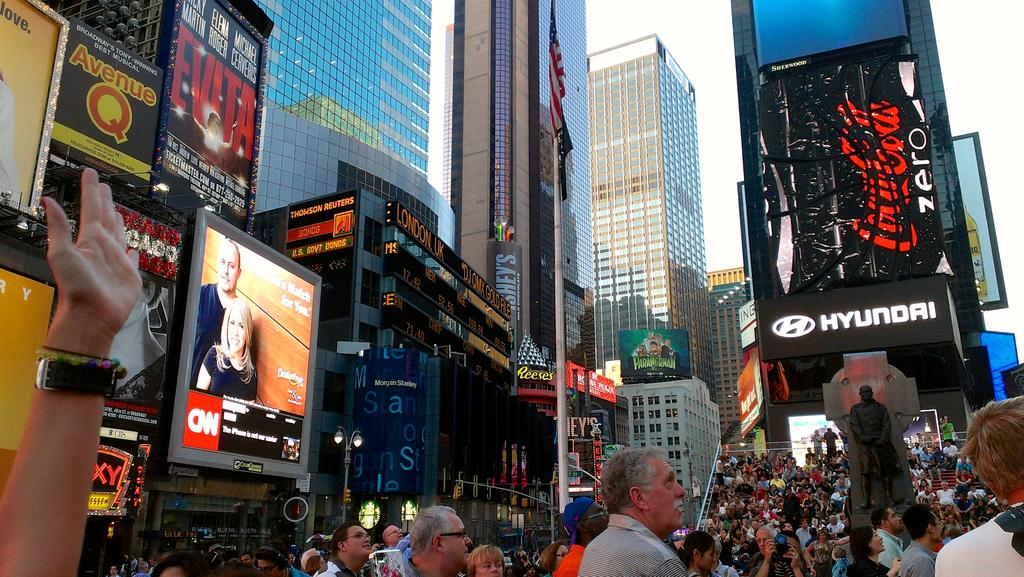What type of structures can be seen in the image? There are buildings in the image. What is placed on top of the buildings? Billboards are present on top of the buildings. What is located in front of the building? There is a flag post in front of the building. What can be seen on the streets in the image? People are visible on the streets. What type of respect can be seen on the buildings in the image? There is no indication of respect in the image; it features buildings with billboards on top and a flag post in front. 